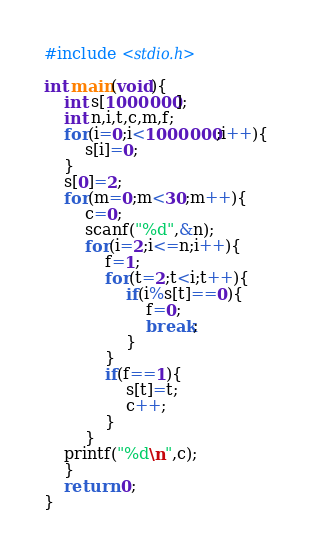<code> <loc_0><loc_0><loc_500><loc_500><_C_>#include <stdio.h>

int main(void){
	int s[1000000];
	int n,i,t,c,m,f;
	for(i=0;i<1000000;i++){
		s[i]=0;
	}
	s[0]=2;
	for(m=0;m<30;m++){
		c=0;
		scanf("%d",&n);
		for(i=2;i<=n;i++){
			f=1;
			for(t=2;t<i;t++){
				if(i%s[t]==0){
					f=0;
					break;
				}
			}
			if(f==1){
				s[t]=t;
				c++;
			}
		}
	printf("%d\n",c);
	}
	return 0;
}</code> 